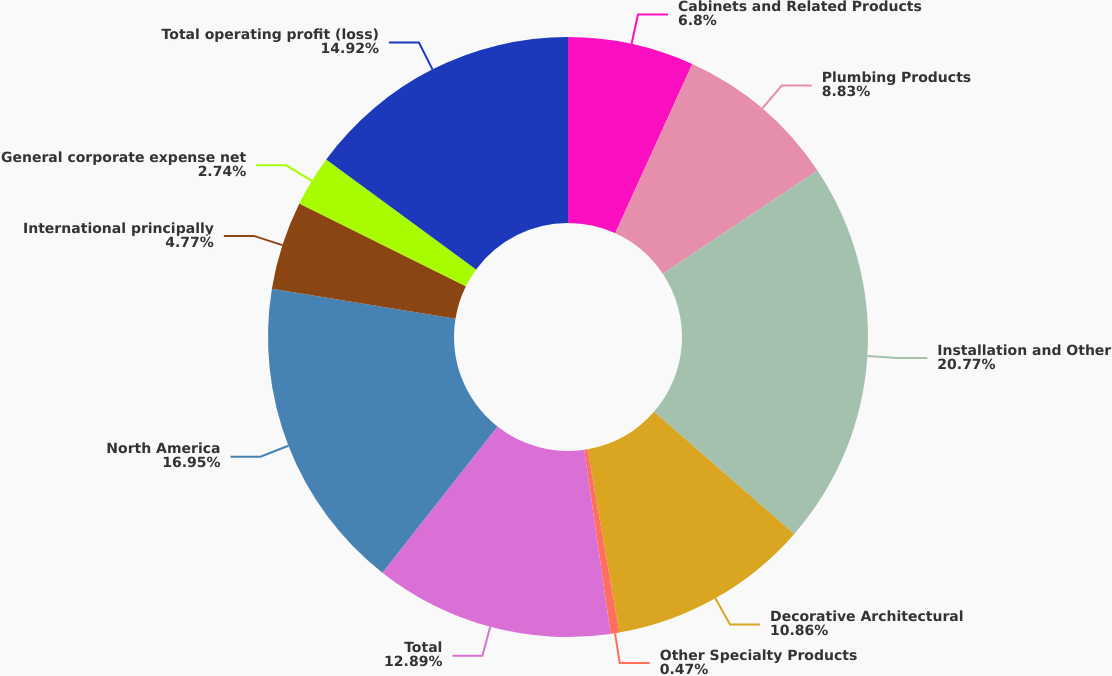<chart> <loc_0><loc_0><loc_500><loc_500><pie_chart><fcel>Cabinets and Related Products<fcel>Plumbing Products<fcel>Installation and Other<fcel>Decorative Architectural<fcel>Other Specialty Products<fcel>Total<fcel>North America<fcel>International principally<fcel>General corporate expense net<fcel>Total operating profit (loss)<nl><fcel>6.8%<fcel>8.83%<fcel>20.77%<fcel>10.86%<fcel>0.47%<fcel>12.89%<fcel>16.95%<fcel>4.77%<fcel>2.74%<fcel>14.92%<nl></chart> 